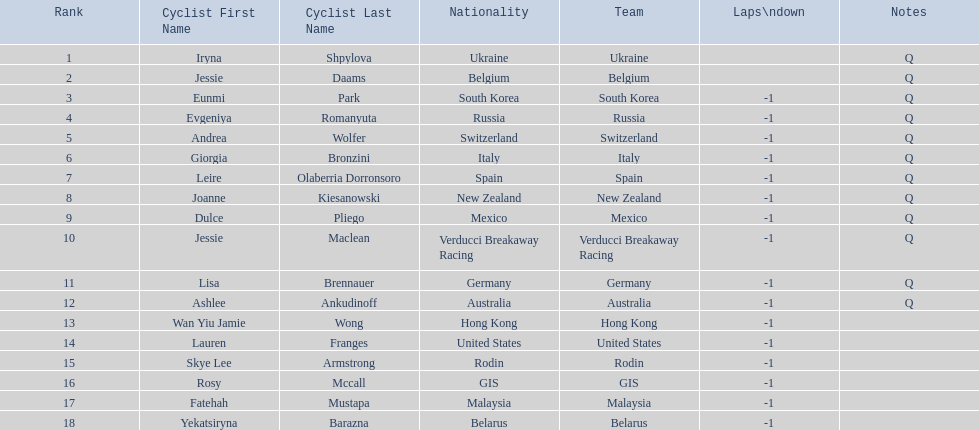Who are all of the cyclists in this race? Iryna Shpylova, Jessie Daams, Eunmi Park, Evgeniya Romanyuta, Andrea Wolfer, Giorgia Bronzini, Leire Olaberria Dorronsoro, Joanne Kiesanowski, Dulce Pliego, Jessie Maclean, Lisa Brennauer, Ashlee Ankudinoff, Wan Yiu Jamie Wong, Lauren Franges, Skye Lee Armstrong, Rosy Mccall, Fatehah Mustapa, Yekatsiryna Barazna. Could you parse the entire table as a dict? {'header': ['Rank', 'Cyclist First Name', 'Cyclist Last Name', 'Nationality', 'Team', 'Laps\\ndown', 'Notes'], 'rows': [['1', 'Iryna', 'Shpylova', 'Ukraine', 'Ukraine', '', 'Q'], ['2', 'Jessie', 'Daams', 'Belgium', 'Belgium', '', 'Q'], ['3', 'Eunmi', 'Park', 'South Korea', 'South Korea', '-1', 'Q'], ['4', 'Evgeniya', 'Romanyuta', 'Russia', 'Russia', '-1', 'Q'], ['5', 'Andrea', 'Wolfer', 'Switzerland', 'Switzerland', '-1', 'Q'], ['6', 'Giorgia', 'Bronzini', 'Italy', 'Italy', '-1', 'Q'], ['7', 'Leire', 'Olaberria Dorronsoro', 'Spain', 'Spain', '-1', 'Q'], ['8', 'Joanne', 'Kiesanowski', 'New Zealand', 'New Zealand', '-1', 'Q'], ['9', 'Dulce', 'Pliego', 'Mexico', 'Mexico', '-1', 'Q'], ['10', 'Jessie', 'Maclean', 'Verducci Breakaway Racing', 'Verducci Breakaway Racing', '-1', 'Q'], ['11', 'Lisa', 'Brennauer', 'Germany', 'Germany', '-1', 'Q'], ['12', 'Ashlee', 'Ankudinoff', 'Australia', 'Australia', '-1', 'Q'], ['13', 'Wan Yiu Jamie', 'Wong', 'Hong Kong', 'Hong Kong', '-1', ''], ['14', 'Lauren', 'Franges', 'United States', 'United States', '-1', ''], ['15', 'Skye Lee', 'Armstrong', 'Rodin', 'Rodin', '-1', ''], ['16', 'Rosy', 'Mccall', 'GIS', 'GIS', '-1', ''], ['17', 'Fatehah', 'Mustapa', 'Malaysia', 'Malaysia', '-1', ''], ['18', 'Yekatsiryna', 'Barazna', 'Belarus', 'Belarus', '-1', '']]} Of these, which one has the lowest numbered rank? Iryna Shpylova. 